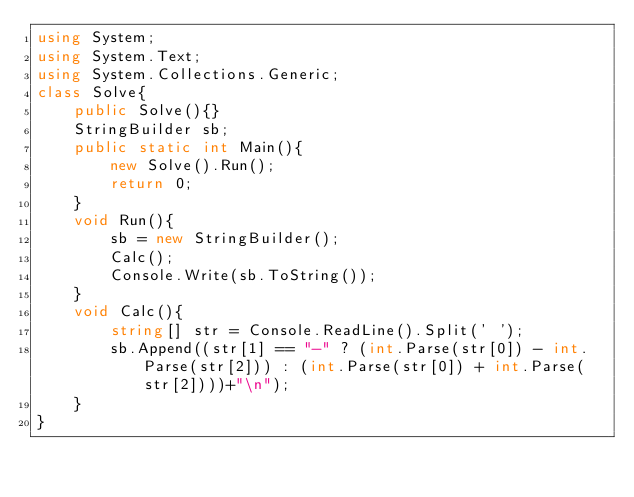Convert code to text. <code><loc_0><loc_0><loc_500><loc_500><_C#_>using System;
using System.Text;
using System.Collections.Generic;
class Solve{
    public Solve(){}
    StringBuilder sb;
    public static int Main(){
        new Solve().Run();
        return 0;
    }
    void Run(){
        sb = new StringBuilder();
        Calc();
        Console.Write(sb.ToString());
    }
    void Calc(){
        string[] str = Console.ReadLine().Split(' ');
        sb.Append((str[1] == "-" ? (int.Parse(str[0]) - int.Parse(str[2])) : (int.Parse(str[0]) + int.Parse(str[2])))+"\n");
    }
}</code> 